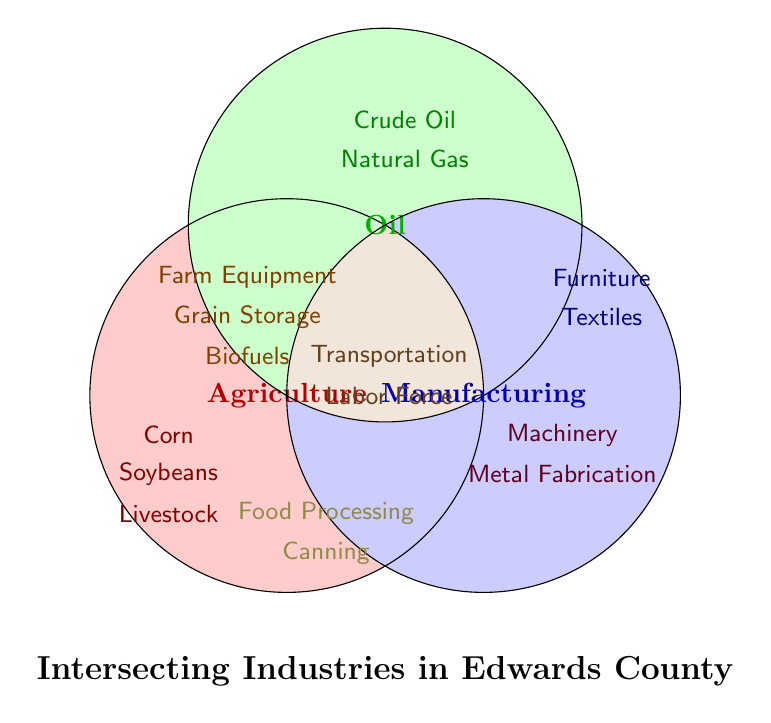What are the three main industries shown in the Venn Diagram? The three main industries in the diagram are indicated by the largest text, which appear inside the three largest and differently colored circles. These industries are Agriculture, Oil, and Manufacturing.
Answer: Agriculture, Oil, Manufacturing Which sectors are common between Agriculture and Oil? To find sectors that are common between Agriculture and Oil, look for elements that fall in the overlapping region of the circles labeled Agriculture (red) and Oil (green). The sectors present in this overlap are Farm Equipment, Grain Storage, and Biofuels.
Answer: Farm Equipment, Grain Storage, Biofuels Are there any sectors shared between all three industries? Sectors shared by all three industries will appear in the central overlap where all three circles intersect. Look here for the relevant labels. The sectors found in this intersection are Transportation and Labor Force.
Answer: Transportation, Labor Force What sector is shared between Oil and Manufacturing but not Agriculture? Look for the overlapping region between the Oil (green) and Manufacturing (blue) circles, excluding the region that also overlaps with Agriculture (red). The sectors in this region are Machinery and Metal Fabrication.
Answer: Machinery, Metal Fabrication List the unique sectors under Manufacturing. To identify sectors unique to Manufacturing, find those that are within the blue circle but not in any overlapping region with either Agriculture (red) or Oil (green). These sectors include Furniture and Textiles.
Answer: Furniture, Textiles Do any sectors intersect between Agriculture and Manufacturing but not with Oil? Check the overlapping region between the Agriculture (red) and Manufacturing (blue) circles, while excluding any sectors that also overlap with Oil (green). The only sector in this region is Food Processing and Canning.
Answer: Food Processing, Canning Which circles overlap directly in the Venn Diagram, creating secondary intersections? Secondary intersections are regions where only two circles overlap. Agriculture (red) overlaps with Oil (green), Agriculture (red) with Manufacturing (blue), and Oil (green) with Manufacturing (blue).
Answer: Agriculture & Oil, Agriculture & Manufacturing, Oil & Manufacturing 